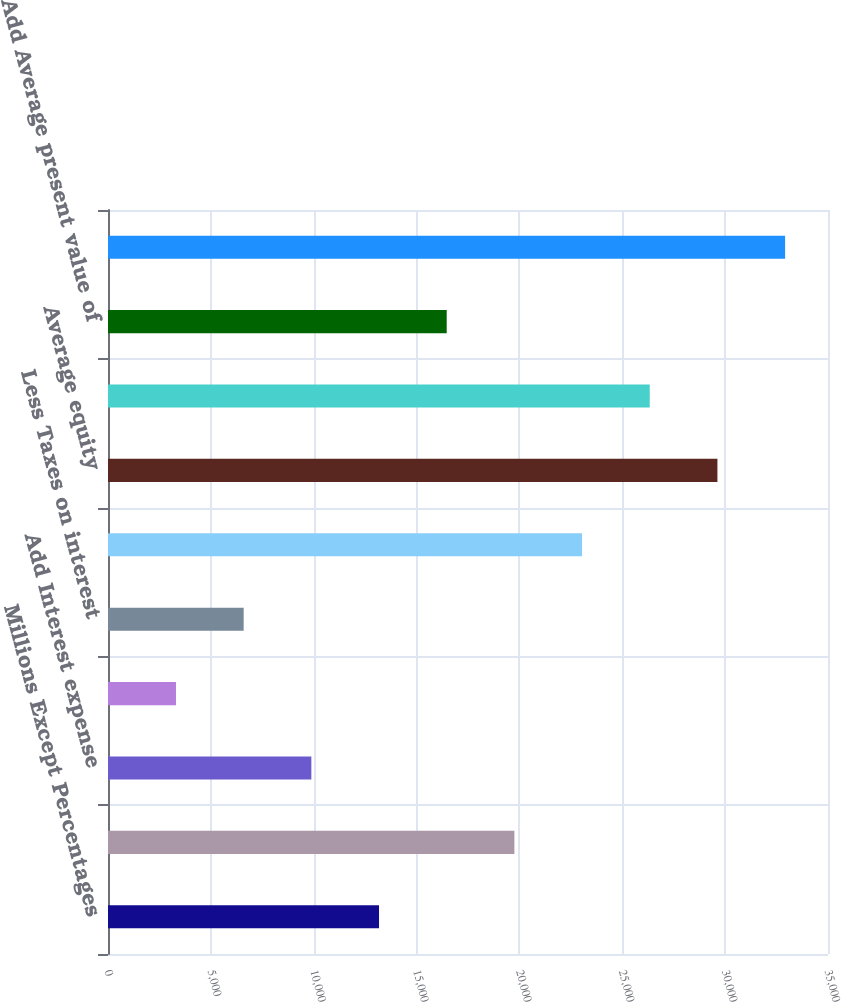<chart> <loc_0><loc_0><loc_500><loc_500><bar_chart><fcel>Millions Except Percentages<fcel>Net income<fcel>Add Interest expense<fcel>Add Interest on present value<fcel>Less Taxes on interest<fcel>Net operating profit after<fcel>Average equity<fcel>Add Average debt<fcel>Add Average present value of<fcel>Average invested capital as<nl><fcel>13174.8<fcel>19754.9<fcel>9884.79<fcel>3304.73<fcel>6594.76<fcel>23044.9<fcel>29625<fcel>26334.9<fcel>16464.8<fcel>32915<nl></chart> 